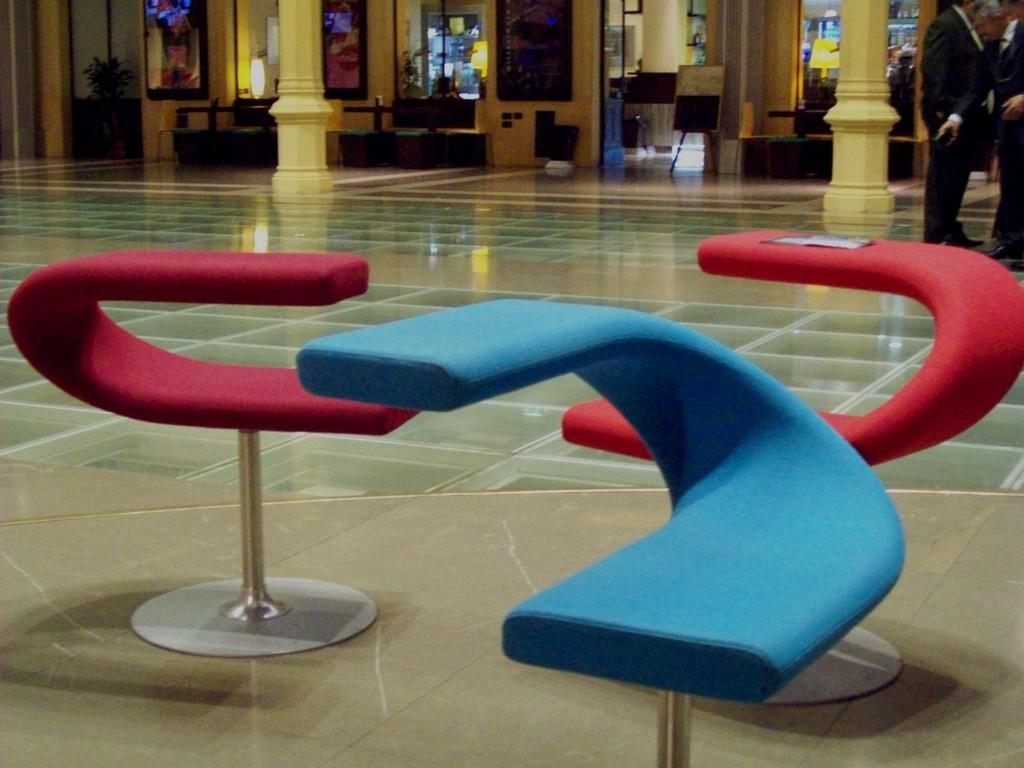Can you describe this image briefly? In this image in the foreground there are some seats, in the background there are some photo frames, plants, lights, pillars and boards and also there are two lamps. On the right side there are some persons who are standing, at the bottom there is a floor. 